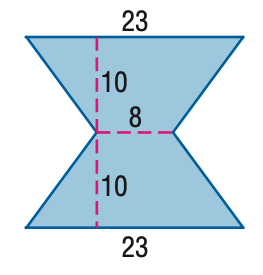Answer the mathemtical geometry problem and directly provide the correct option letter.
Question: Find the area of the figure. Round to the nearest tenth if necessary.
Choices: A: 210 B: 230 C: 310 D: 460 C 